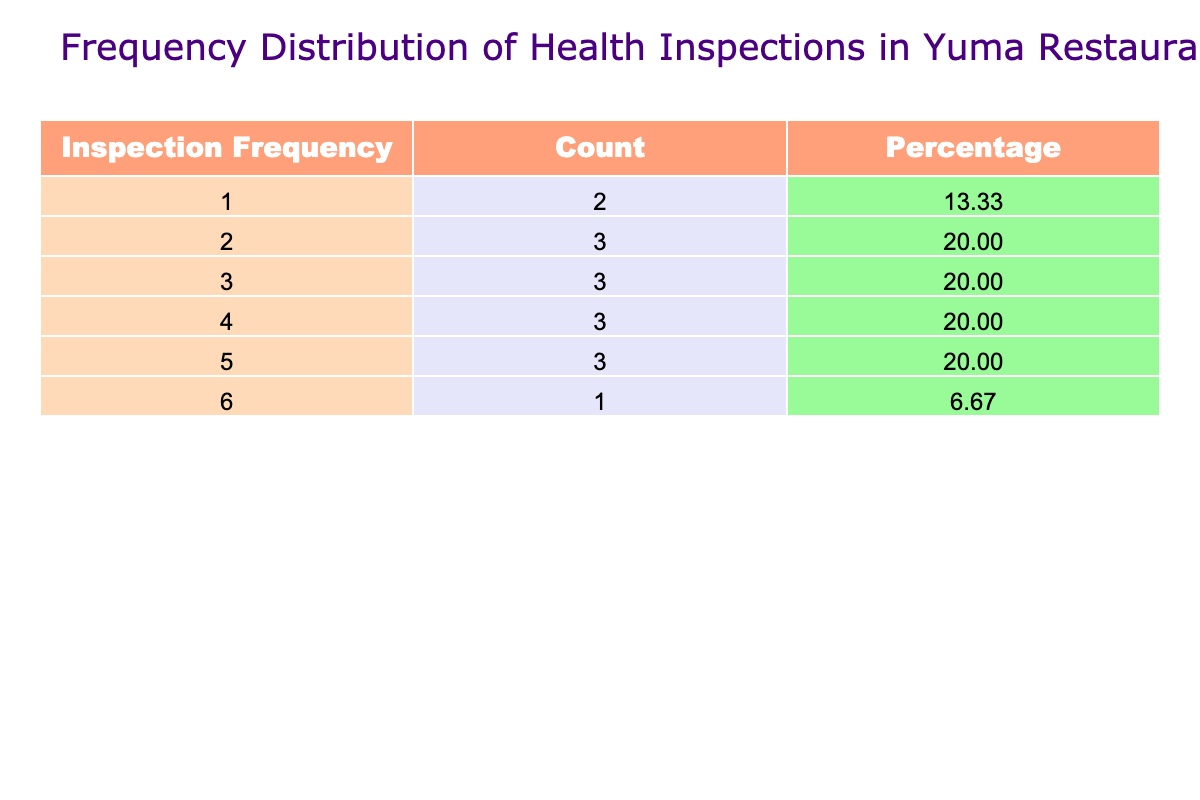What is the total number of restaurants inspected with a frequency of 2? From the table, the frequency of 2 appears in the "Inspection Frequency" column for three restaurants: El Charro, The Pecan Grill, and Golden Corral. Therefore, the total number of restaurants with this frequency is 3.
Answer: 3 What is the percentage of restaurants that have an inspection frequency of 5? The table shows that there are three restaurants (Café 105, Crazy Jim’s BBQ, and Sushi Train) with an inspection frequency of 5. The total number of restaurants is 15. The percentage is calculated as (3/15) * 100 = 20%.
Answer: 20% What is the average inspection frequency among all the restaurants listed? First, sum the inspection frequencies of all restaurants: 2 + 3 + 4 + 5 + 3 + 4 + 6 + 2 + 5 + 4 + 1 + 2 + 3 + 5 + 1 = 52. Since there are 15 restaurants, the average frequency is 52/15, which equals approximately 3.47.
Answer: 3.47 Are there more restaurants with a frequency of 4 than with a frequency of 3? The table lists four restaurants with an inspection frequency of 4 (Lettuce Eat, La Fonda, Desert Sunset Diner, and Café 105) and three restaurants with a frequency of 3 (The Yuma Palms, Yuma River Grill, and Gila Monster). Therefore, there are more restaurants with a frequency of 4.
Answer: Yes What is the difference in the count of restaurants between the frequencies of 6 and 1? There is 1 restaurant with a frequency of 6 (Dirty’s Kitchen) and 2 restaurants with a frequency of 1 (Fiesta Mexican Grill and Starbucks Yuma). The difference is calculated as 1 - 2 = -1, indicating that there are more restaurants with a frequency of 1.
Answer: -1 Which inspection frequency has the highest count, and how many restaurants have that frequency? The inspection frequency of 6 has the highest count with only 1 restaurant (Dirty’s Kitchen). To determine the highest frequency, compare all counts; the maximum is identified as having a frequency of 6.
Answer: 6 Which restaurant appears with the least frequency in the inspections? The restaurant with the least inspection frequency is Fiesta Mexican Grill, which has a frequency of 1. When scanning the table, it is noted that this is the only restaurant with this particular frequency.
Answer: Fiesta Mexican Grill How many restaurants have inspection frequencies of 4 or higher? The frequencies of 4 or higher are 4 (Lettuce Eat), 5 (Café 105, Crazy Jim's BBQ, Sushi Train), and 6 (Dirty's Kitchen). The restaurants with 4 or higher are Lettuce Eat, Café 105, Crazy Jim's BBQ, Sushi Train, and Dirty’s Kitchen. Therefore, a total of 6 restaurants belong to this category.
Answer: 6 